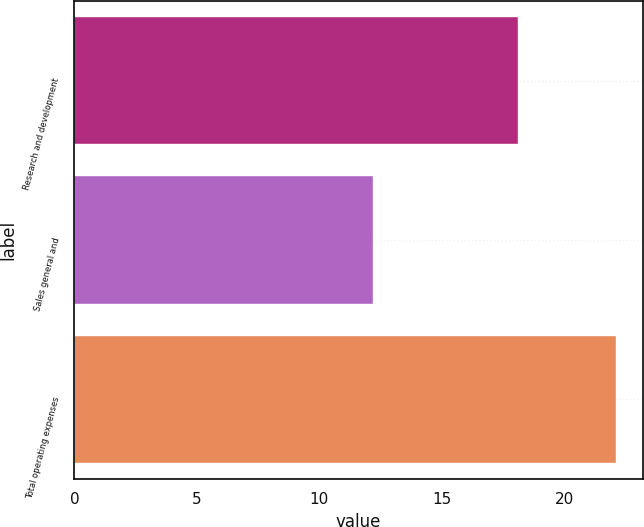<chart> <loc_0><loc_0><loc_500><loc_500><bar_chart><fcel>Research and development<fcel>Sales general and<fcel>Total operating expenses<nl><fcel>18.1<fcel>12.2<fcel>22.1<nl></chart> 